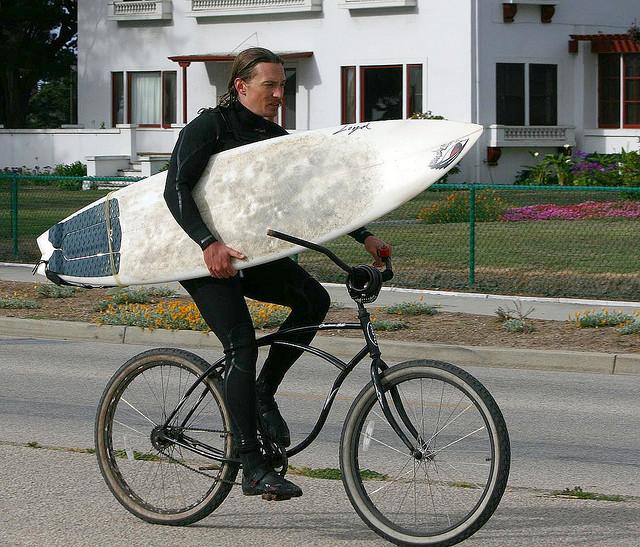What color is the gate?
Write a very short answer. Green. What color is the bike?
Answer briefly. Black. What is the man riding?
Keep it brief. Bicycle. How long is the surfboard?
Keep it brief. 6 ft. 